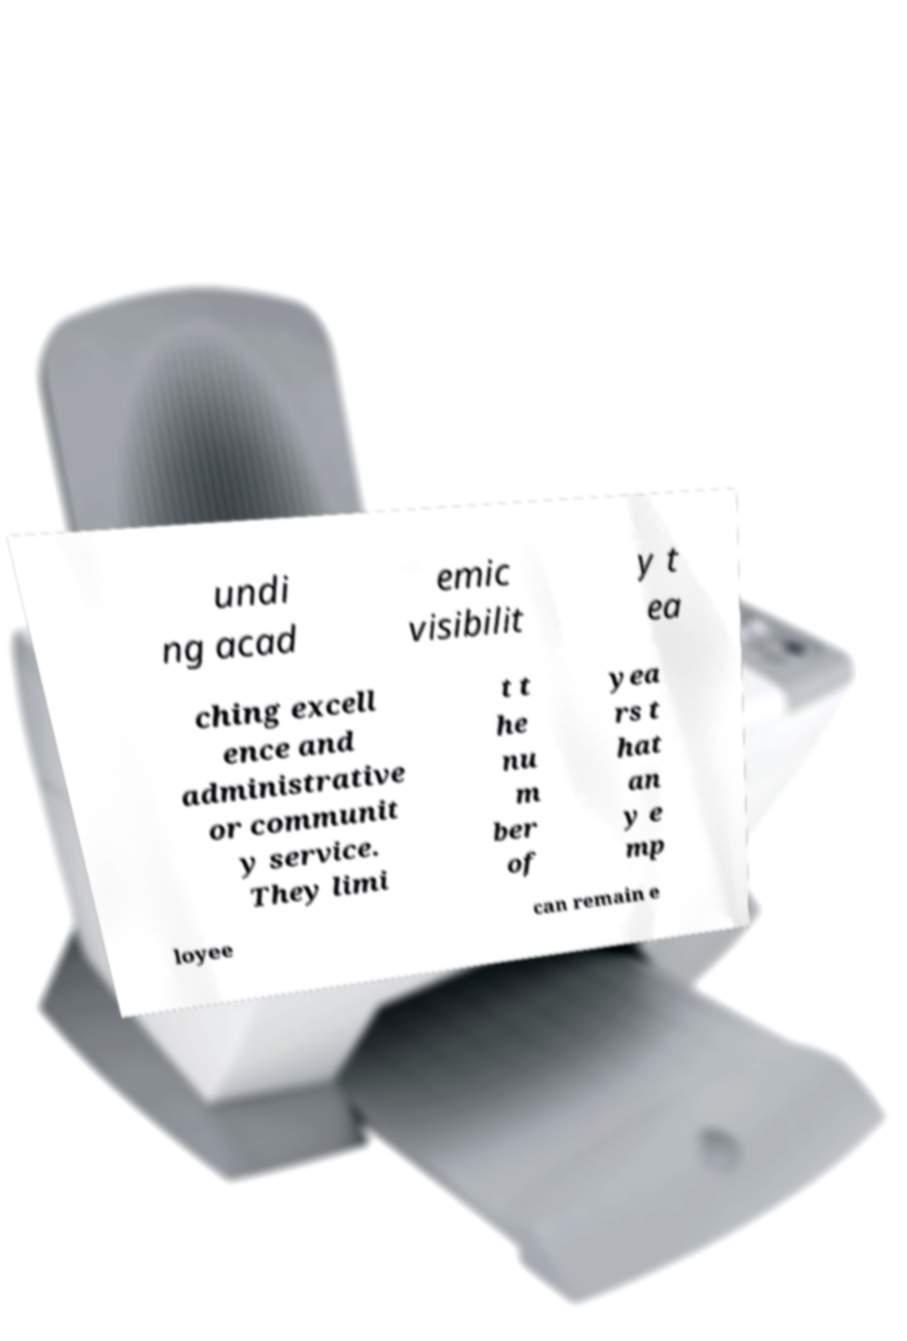I need the written content from this picture converted into text. Can you do that? undi ng acad emic visibilit y t ea ching excell ence and administrative or communit y service. They limi t t he nu m ber of yea rs t hat an y e mp loyee can remain e 